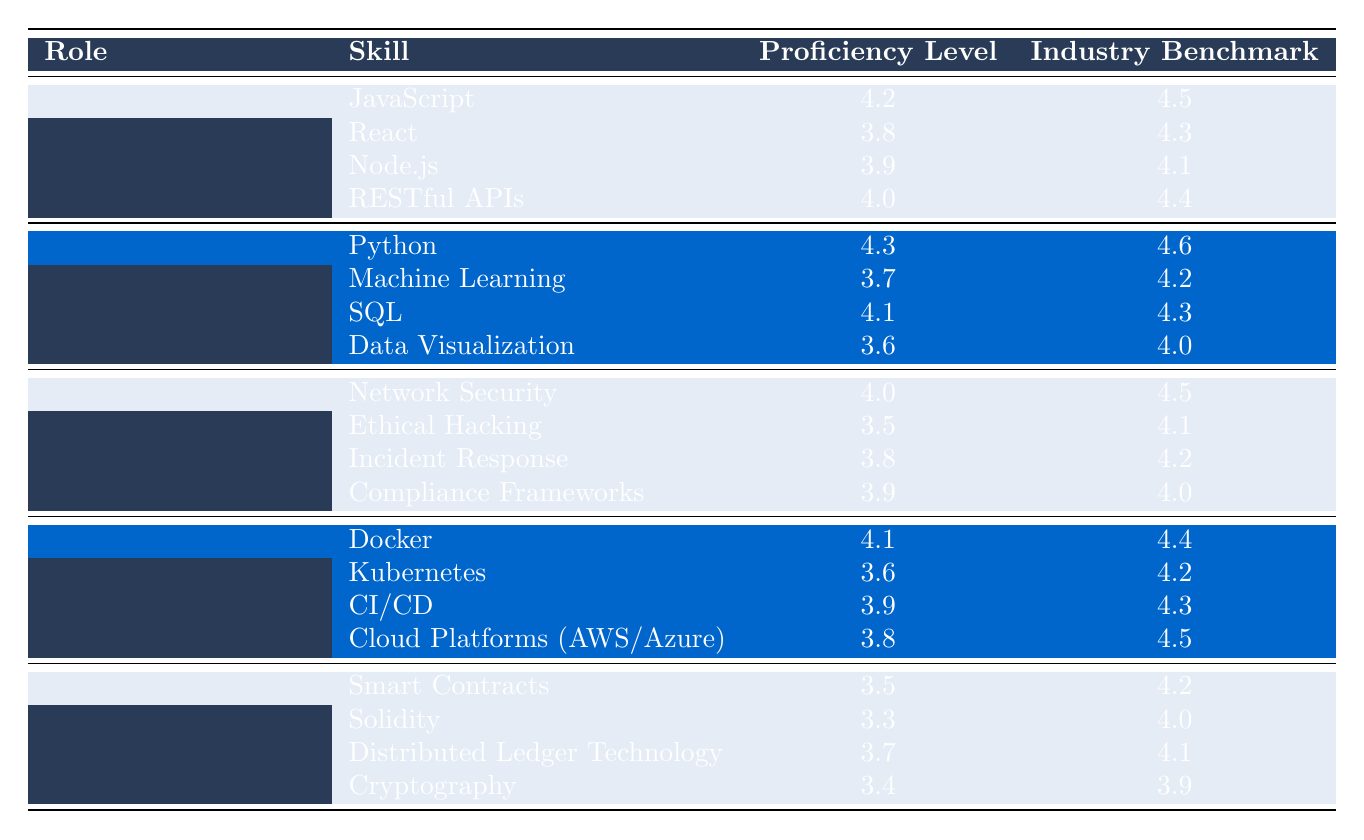What is the proficiency level of Full Stack Developer in JavaScript? The table indicates that the Proficiency Level for the skill JavaScript under the Full Stack Developer role is 4.2.
Answer: 4.2 What is the industry benchmark for Data Visualization for Data Scientists? According to the table, the Industry Benchmark for the skill Data Visualization under the Data Scientist role is 4.0.
Answer: 4.0 Is the proficiency level of Cybersecurity Analysts higher or lower than the industry benchmark for Incident Response? The proficiency level for Incident Response under Cybersecurity Analyst is 3.8, which is lower than the industry benchmark of 4.2, making the statement true.
Answer: Lower Which role has the highest average proficiency level based on the skills listed? To find the average, we sum the proficiency levels: Full Stack Developer: (4.2 + 3.8 + 3.9 + 4.0) / 4 = 4.0, Data Scientist: (4.3 + 3.7 + 4.1 + 3.6) / 4 = 3.925, Cybersecurity Analyst: (4.0 + 3.5 + 3.8 + 3.9) / 4 = 3.815, DevOps Engineer: (4.1 + 3.6 + 3.9 + 3.8) / 4 = 3.85, Blockchain Developer: (3.5 + 3.3 + 3.7 + 3.4) / 4 = 3.475. Full Stack Developer has the highest average of 4.0.
Answer: Full Stack Developer What is the overall skill gap for Python for Data Scientists? The skill gap is calculated by subtracting the Proficiency Level from the Industry Benchmark: 4.6 (benchmark) - 4.3 (current level) = 0.3. Therefore, the overall skill gap for Python is 0.3.
Answer: 0.3 Identify which role experiences the largest skill gap on average across all skills. First, calculate the skill gap for each skill in every role: Full Stack Developer: (4.5-4.2 + 4.3-3.8 + 4.1-3.9 + 4.4-4.0)/4 = 0.35, Data Scientist: (4.6-4.3 + 4.2-3.7 + 4.3-4.1 + 4.0-3.6)/4 = 0.325, Cybersecurity Analyst: (4.5-4.0 + 4.1-3.5 + 4.2-3.8 + 4.0-3.9)/4 = 0.325, DevOps Engineer: (4.4-4.1 + 4.2-3.6 + 4.3-3.9 + 4.5-3.8)/4 = 0.375, Blockchain Developer: (4.2-3.5 + 4.0-3.3 + 4.1-3.7 + 3.9-3.4)/4 = 0.475. Thus, the role with the largest average skill gap is Blockchain Developer at 0.475.
Answer: Blockchain Developer 